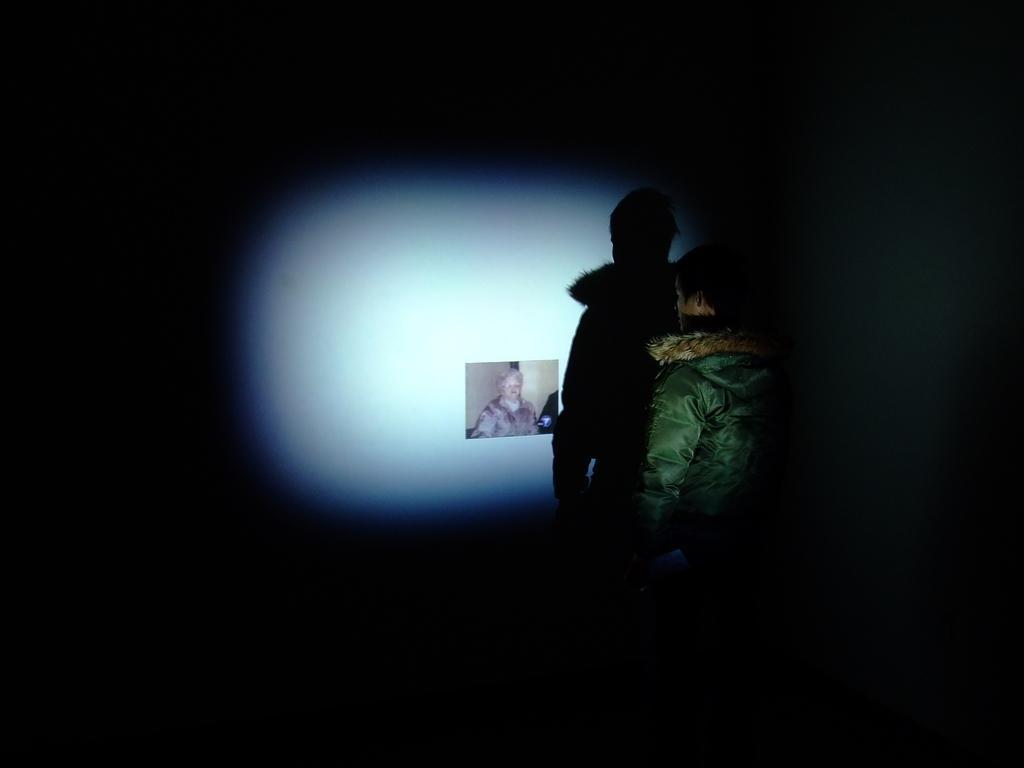In one or two sentences, can you explain what this image depicts? This is an image clicked in the dark. In the middle of the image I can see a person wearing a jacket and standing in front of the wall. In the wall I can see a photo is attached. 